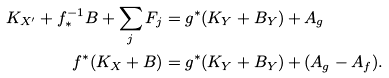Convert formula to latex. <formula><loc_0><loc_0><loc_500><loc_500>K _ { X ^ { \prime } } + f ^ { - 1 } _ { * } B + \sum _ { j } F _ { j } & = g ^ { * } ( K _ { Y } + B _ { Y } ) + A _ { g } \\ f ^ { * } ( K _ { X } + B ) & = g ^ { * } ( K _ { Y } + B _ { Y } ) + ( A _ { g } - A _ { f } ) .</formula> 